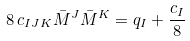Convert formula to latex. <formula><loc_0><loc_0><loc_500><loc_500>8 \, c _ { I J K } \bar { M } ^ { J } \bar { M } ^ { K } = q _ { I } + \frac { c _ { I } } { 8 }</formula> 